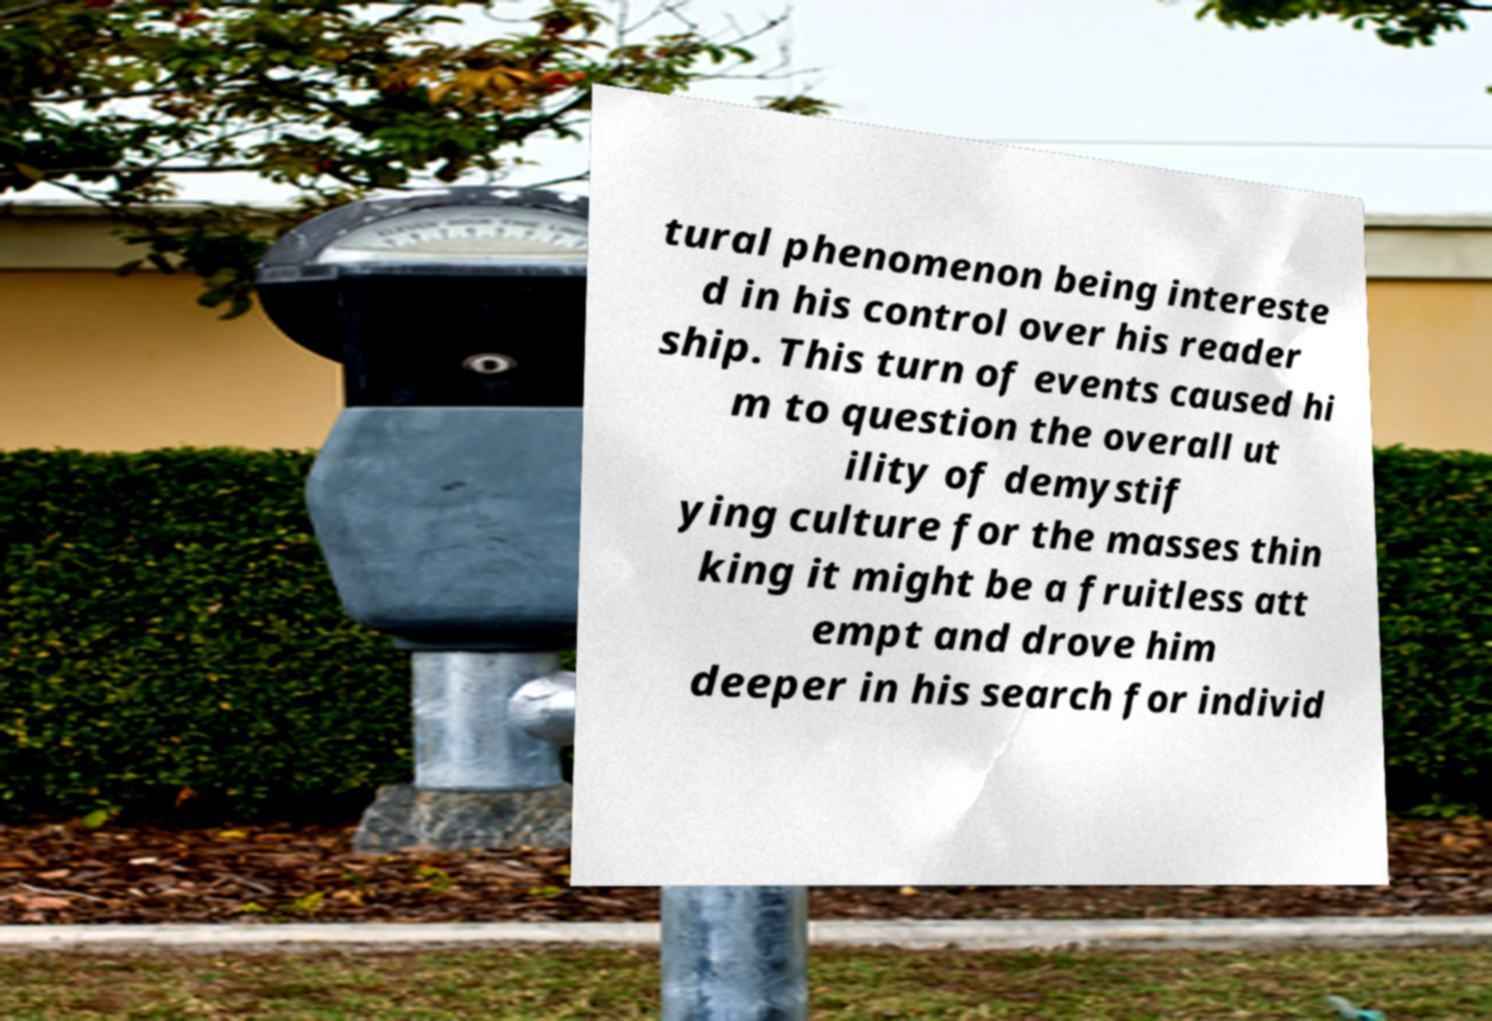There's text embedded in this image that I need extracted. Can you transcribe it verbatim? tural phenomenon being intereste d in his control over his reader ship. This turn of events caused hi m to question the overall ut ility of demystif ying culture for the masses thin king it might be a fruitless att empt and drove him deeper in his search for individ 